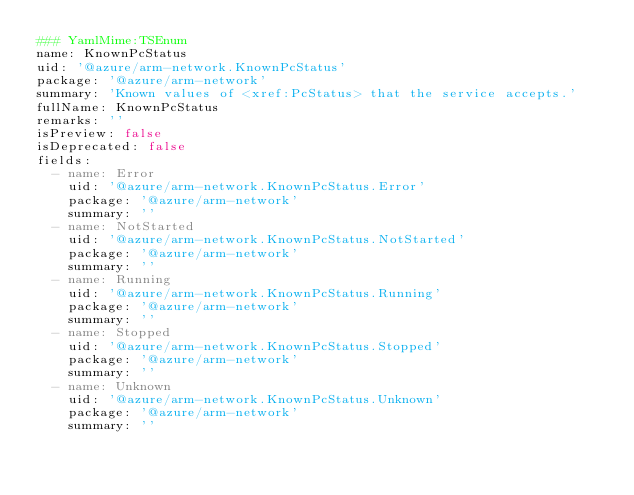<code> <loc_0><loc_0><loc_500><loc_500><_YAML_>### YamlMime:TSEnum
name: KnownPcStatus
uid: '@azure/arm-network.KnownPcStatus'
package: '@azure/arm-network'
summary: 'Known values of <xref:PcStatus> that the service accepts.'
fullName: KnownPcStatus
remarks: ''
isPreview: false
isDeprecated: false
fields:
  - name: Error
    uid: '@azure/arm-network.KnownPcStatus.Error'
    package: '@azure/arm-network'
    summary: ''
  - name: NotStarted
    uid: '@azure/arm-network.KnownPcStatus.NotStarted'
    package: '@azure/arm-network'
    summary: ''
  - name: Running
    uid: '@azure/arm-network.KnownPcStatus.Running'
    package: '@azure/arm-network'
    summary: ''
  - name: Stopped
    uid: '@azure/arm-network.KnownPcStatus.Stopped'
    package: '@azure/arm-network'
    summary: ''
  - name: Unknown
    uid: '@azure/arm-network.KnownPcStatus.Unknown'
    package: '@azure/arm-network'
    summary: ''
</code> 